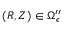<formula> <loc_0><loc_0><loc_500><loc_500>( R , Z ) \in \Omega _ { \epsilon } ^ { \prime \prime }</formula> 